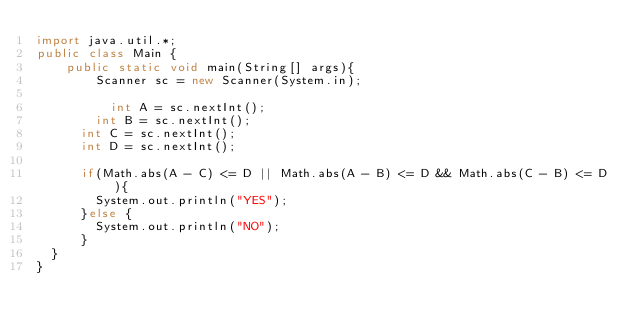<code> <loc_0><loc_0><loc_500><loc_500><_Java_>import java.util.*;
public class Main {
	public static void main(String[] args){
		Scanner sc = new Scanner(System.in);

		  int A = sc.nextInt();
	    int B = sc.nextInt();
      int C = sc.nextInt();
      int D = sc.nextInt();

      if(Math.abs(A - C) <= D || Math.abs(A - B) <= D && Math.abs(C - B) <= D){
      	System.out.println("YES");
      }else {
        System.out.println("NO");
      }
  }
}
</code> 